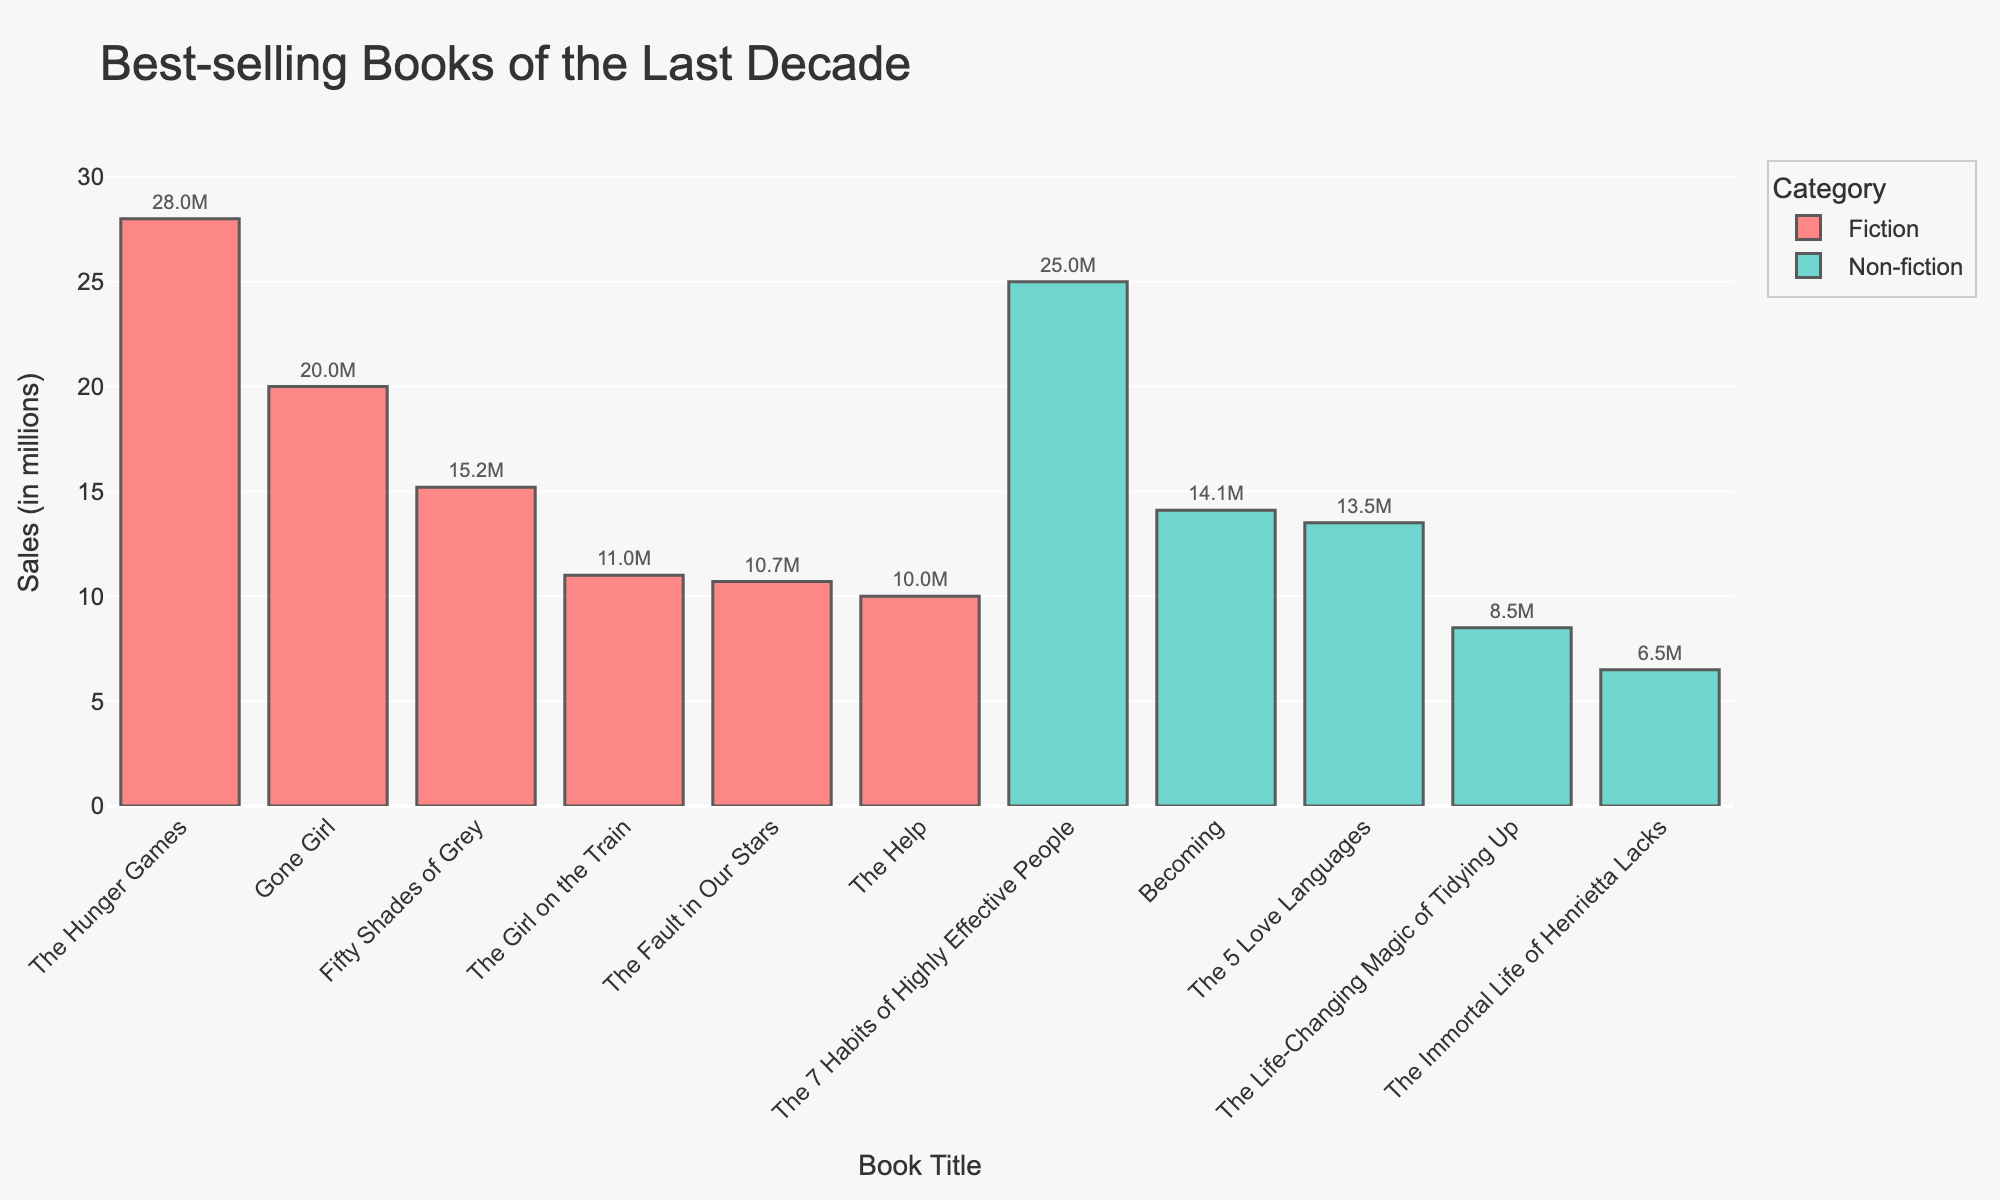What is the best-selling book in the last decade? The best-selling book will be the one with the highest bar in the chart. "The Hunger Games" is the tallest bar.
Answer: "The Hunger Games" Which category has more total sales, Fiction or Non-fiction? Add up the sales of books in the Fiction category and compare to the sum of sales in Non-fiction. Fiction has 28 + 15.2 + 20 + 10.7 + 11 + 10 = 94.9 million, Non-fiction has 14.1 + 25 + 8.5 + 13.5 + 6.5 = 67.6 million.
Answer: Fiction What is the total sales of "The Hunger Games" and "The 7 Habits of Highly Effective People"? Sum the sales figures of both titles: 28 + 25 = 53
Answer: 53 Which book in the Non-fiction category has the lowest sales? The book with the shortest bar among Non-fiction titles is "The Immortal Life of Henrietta Lacks".
Answer: "The Immortal Life of Henrietta Lacks" How much more did "Gone Girl" sell than "The Fault in Our Stars"? Subtract the sales of "The Fault in Our Stars" from "Gone Girl": 20 - 10.7 = 9.3
Answer: 9.3 Which two Fiction books have the closest sales numbers? Compare the heights of the bars within the Fiction category and find the pair with the smallest difference. "The Fault in Our Stars" (10.7) and "The Help" (10) have the closest sales with a difference of 0.7 million.
Answer: "The Fault in Our Stars" and "The Help" Is "Becoming" selling more or less than "Fifty Shades of Grey"? Compare the heights of the bars for both titles. "Fifty Shades of Grey" has sales of 15.2 million and "Becoming" has sales of 14.1 million, so "Becoming" is selling less.
Answer: Less What is the average sales of the Fiction books listed? Sum the sales figures for all Fiction books and divide by the number of books: (28 + 15.2 + 20 + 10.7 + 11 + 10)/6 = 15.82 million.
Answer: 15.82 Which book has the second highest sales overall? Identify the second tallest bar among all shown. "The 7 Habits of Highly Effective People" with sales of 25 million is the second highest.
Answer: "The 7 Habits of Highly Effective People" What is the difference in sales between the highest-selling Non-fiction and the lowest-selling Fiction book? Subtract the sales of "The Help" (lowest Fiction) from "The 7 Habits of Highly Effective People" (highest Non-fiction): 25 - 10 = 15.
Answer: 15 